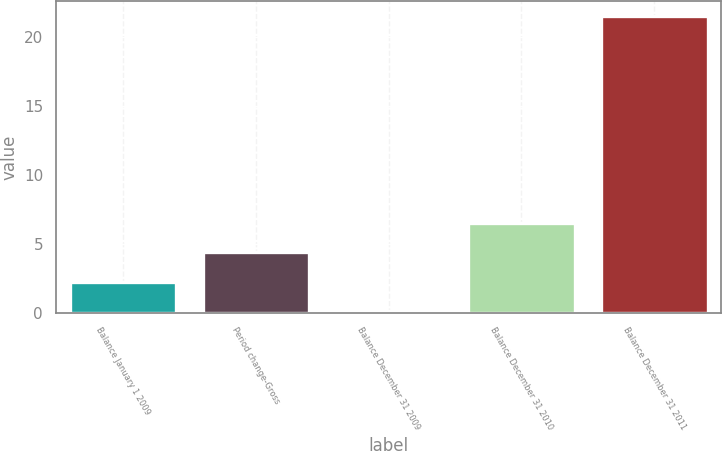<chart> <loc_0><loc_0><loc_500><loc_500><bar_chart><fcel>Balance January 1 2009<fcel>Period change-Gross<fcel>Balance December 31 2009<fcel>Balance December 31 2010<fcel>Balance December 31 2011<nl><fcel>2.24<fcel>4.38<fcel>0.1<fcel>6.52<fcel>21.5<nl></chart> 